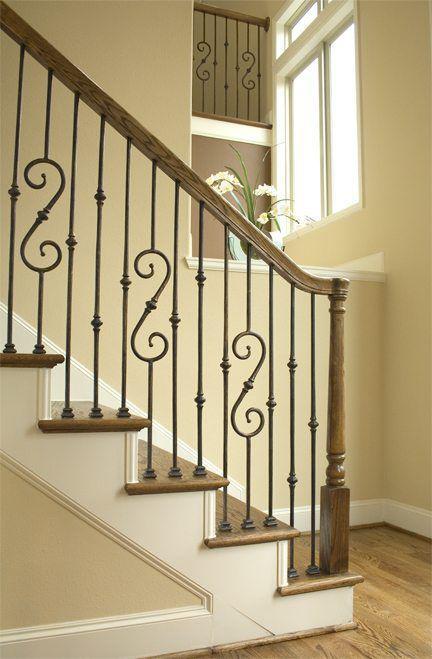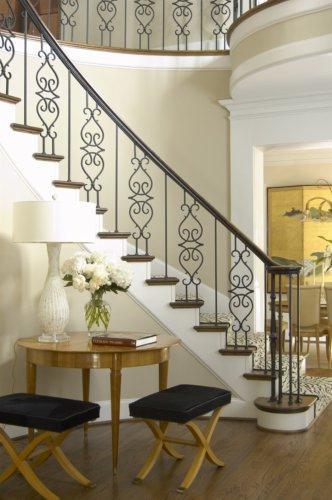The first image is the image on the left, the second image is the image on the right. For the images shown, is this caption "The staircase on the left has a banister featuring cast iron bars with scroll details, and the staircase on the right has slender spindles." true? Answer yes or no. No. 